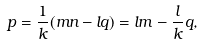Convert formula to latex. <formula><loc_0><loc_0><loc_500><loc_500>p = \frac { 1 } { k } ( m n - l q ) = l m - \frac { l } { k } q ,</formula> 